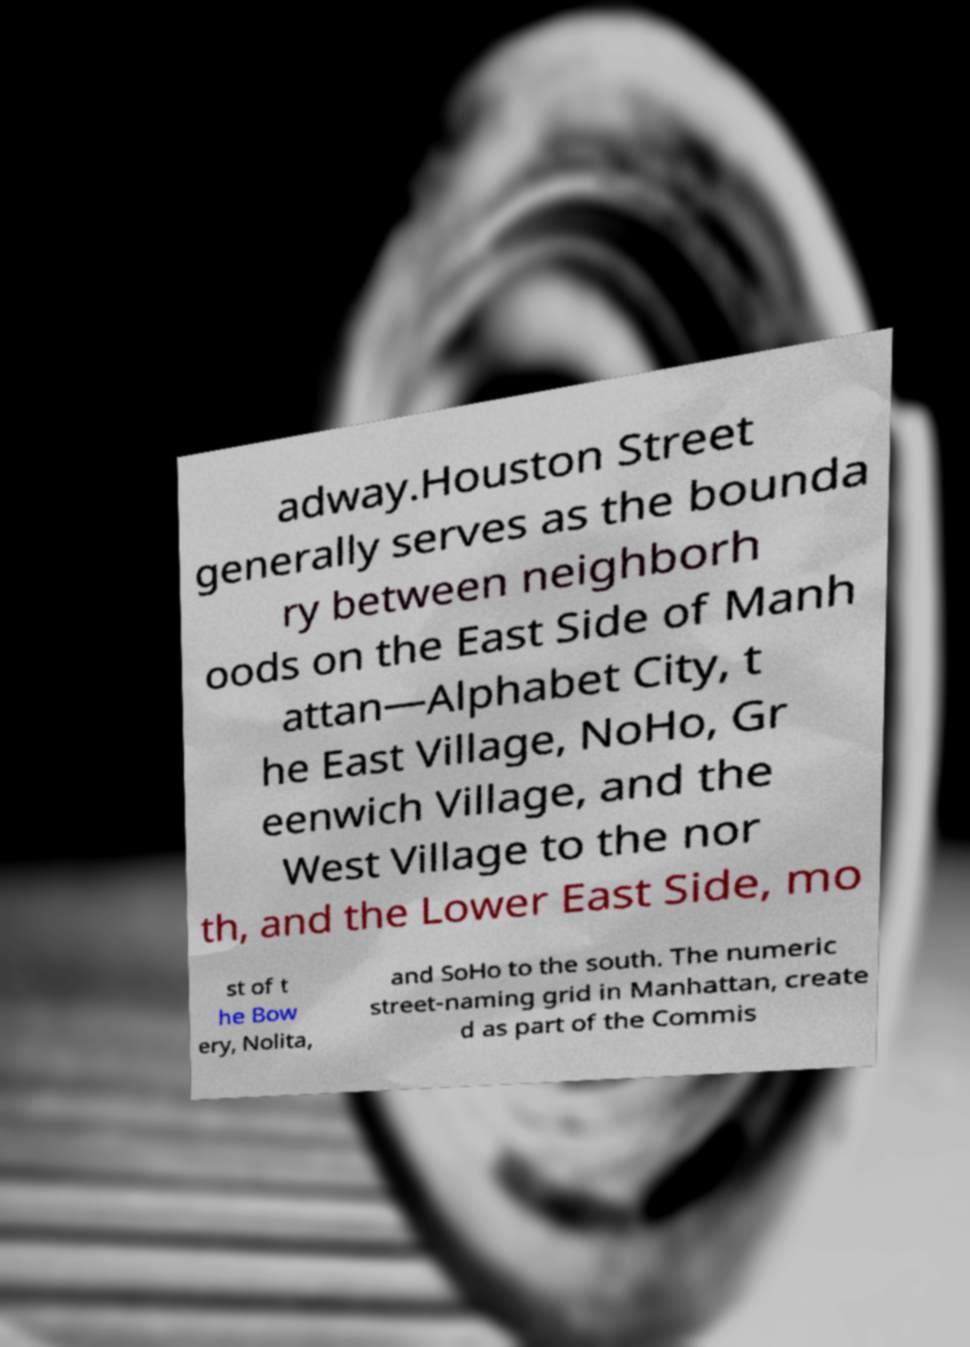Please identify and transcribe the text found in this image. adway.Houston Street generally serves as the bounda ry between neighborh oods on the East Side of Manh attan—Alphabet City, t he East Village, NoHo, Gr eenwich Village, and the West Village to the nor th, and the Lower East Side, mo st of t he Bow ery, Nolita, and SoHo to the south. The numeric street-naming grid in Manhattan, create d as part of the Commis 